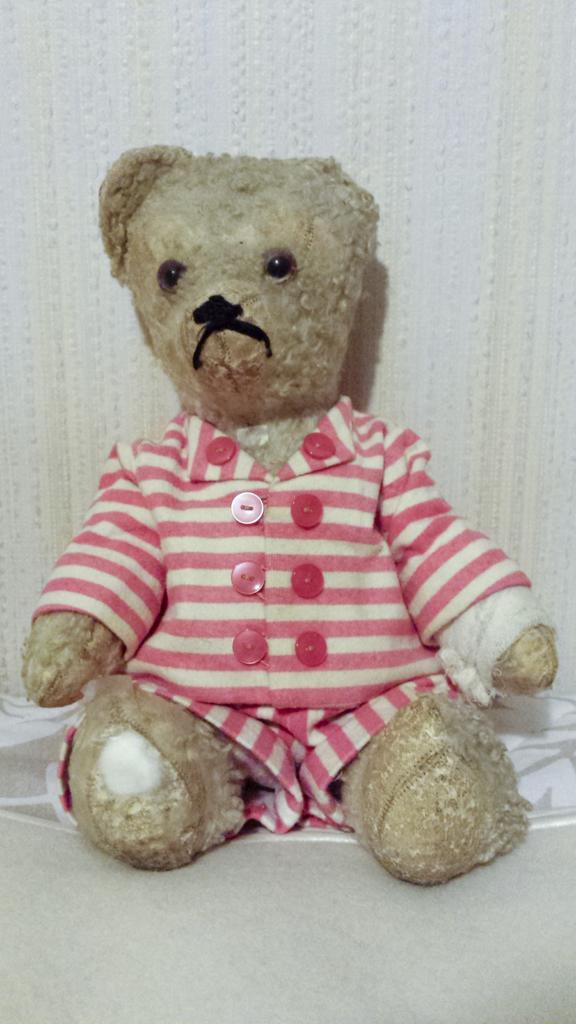In one or two sentences, can you explain what this image depicts? In this image I can see the toy on the white color surface. I can see the dress to the toy which is in white and pink color. And there is a white background. 